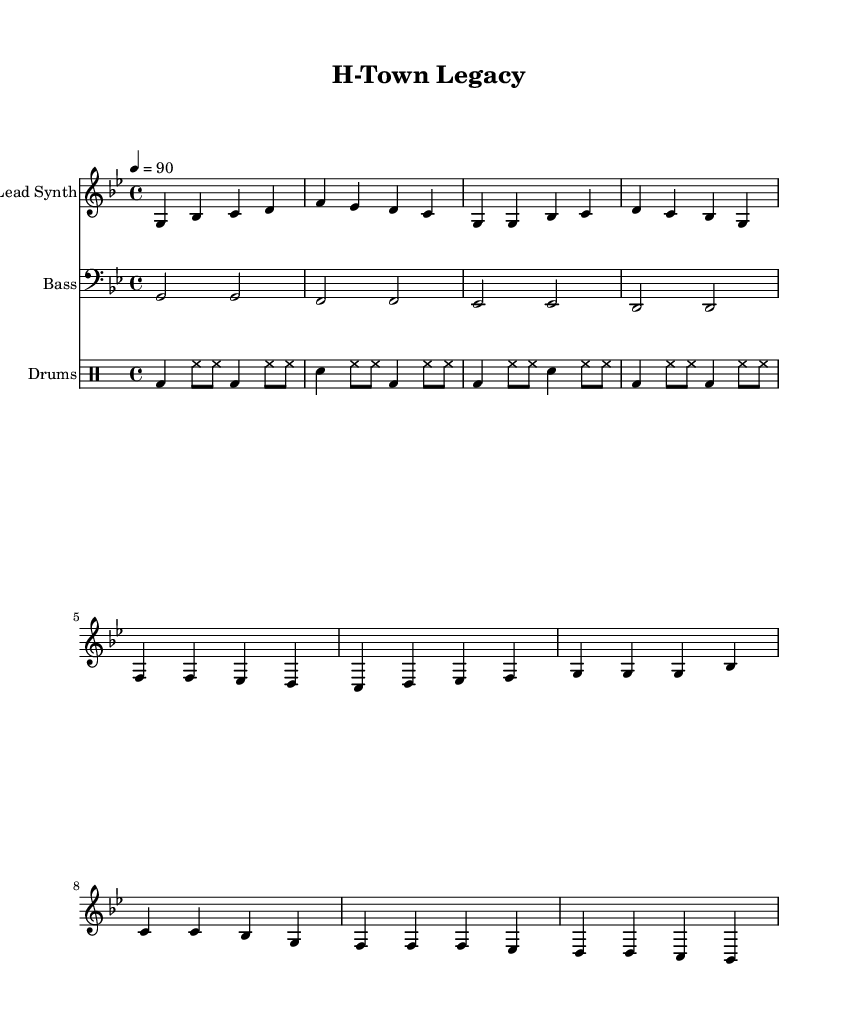What is the key signature of this music? The key signature is G minor, which has two flats: B flat and E flat.
Answer: G minor What is the time signature of this music? The time signature is four beats per measure, represented as 4/4 at the beginning of the score.
Answer: 4/4 What is the tempo marking for this piece? The tempo marking indicates a speed of 90 beats per minute, as shown by the tempo notation 4 = 90.
Answer: 90 How many measures are in the chorus section? The chorus consists of 4 measures, which can be counted by observing the grouping of notes in that section of the score.
Answer: 4 What type of instruments are featured in this score? The score features a lead synth, bass, and drums, as indicated in the respective staves.
Answer: Lead Synth, Bass, Drums Which section contains the repeated note pattern? The verse section contains the repeated note pattern, identifiable by multiple G notes in succession.
Answer: Verse What is the rhythmic pattern of the drums? The drum pattern is characterized by kick drums, hi-hats, and snare drums, creating a consistent hip hop beat, indicated by the drummode notation.
Answer: Kick, Hi-Hat, Snare 